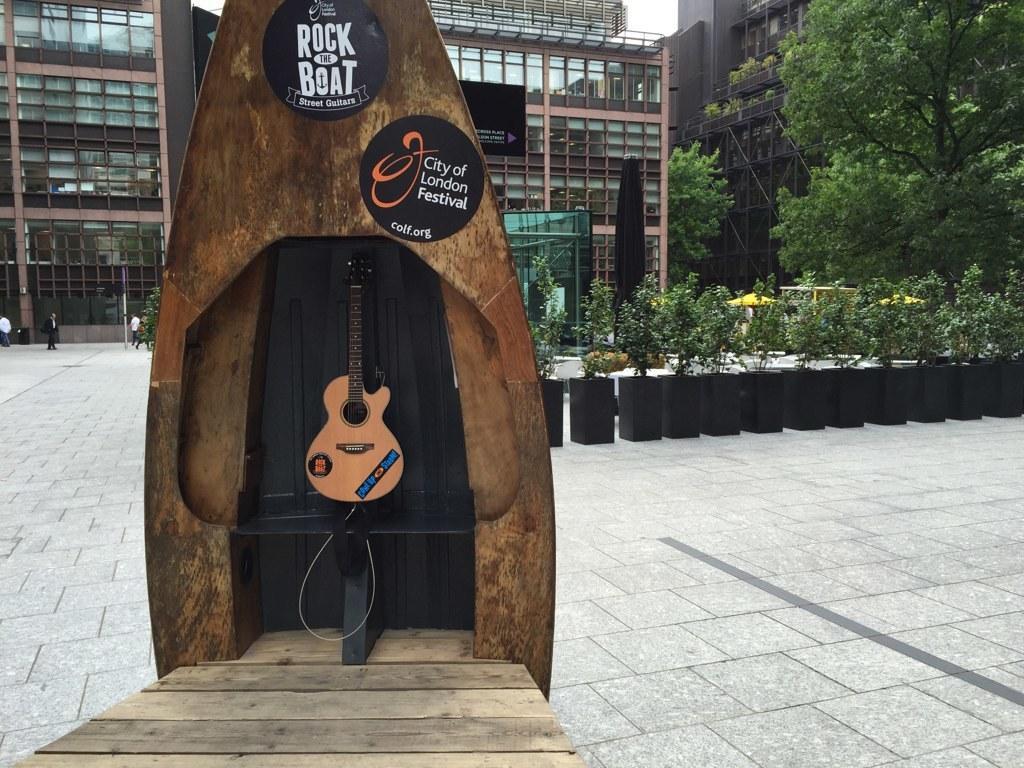In one or two sentences, can you explain what this image depicts? As we can see in the image there are buildings, trees, plants and a guitar. 